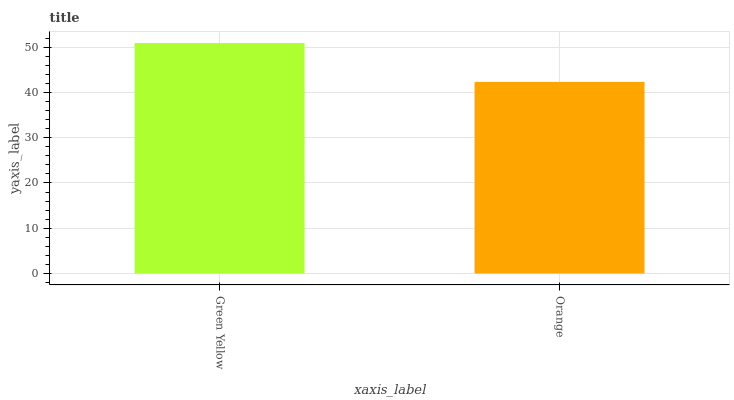Is Orange the minimum?
Answer yes or no. Yes. Is Green Yellow the maximum?
Answer yes or no. Yes. Is Orange the maximum?
Answer yes or no. No. Is Green Yellow greater than Orange?
Answer yes or no. Yes. Is Orange less than Green Yellow?
Answer yes or no. Yes. Is Orange greater than Green Yellow?
Answer yes or no. No. Is Green Yellow less than Orange?
Answer yes or no. No. Is Green Yellow the high median?
Answer yes or no. Yes. Is Orange the low median?
Answer yes or no. Yes. Is Orange the high median?
Answer yes or no. No. Is Green Yellow the low median?
Answer yes or no. No. 